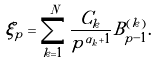<formula> <loc_0><loc_0><loc_500><loc_500>\xi _ { p } = \sum _ { k = 1 } ^ { N } \frac { C _ { k } } { p ^ { \alpha _ { k } + 1 } } B ^ { ( k ) } _ { p - 1 } .</formula> 